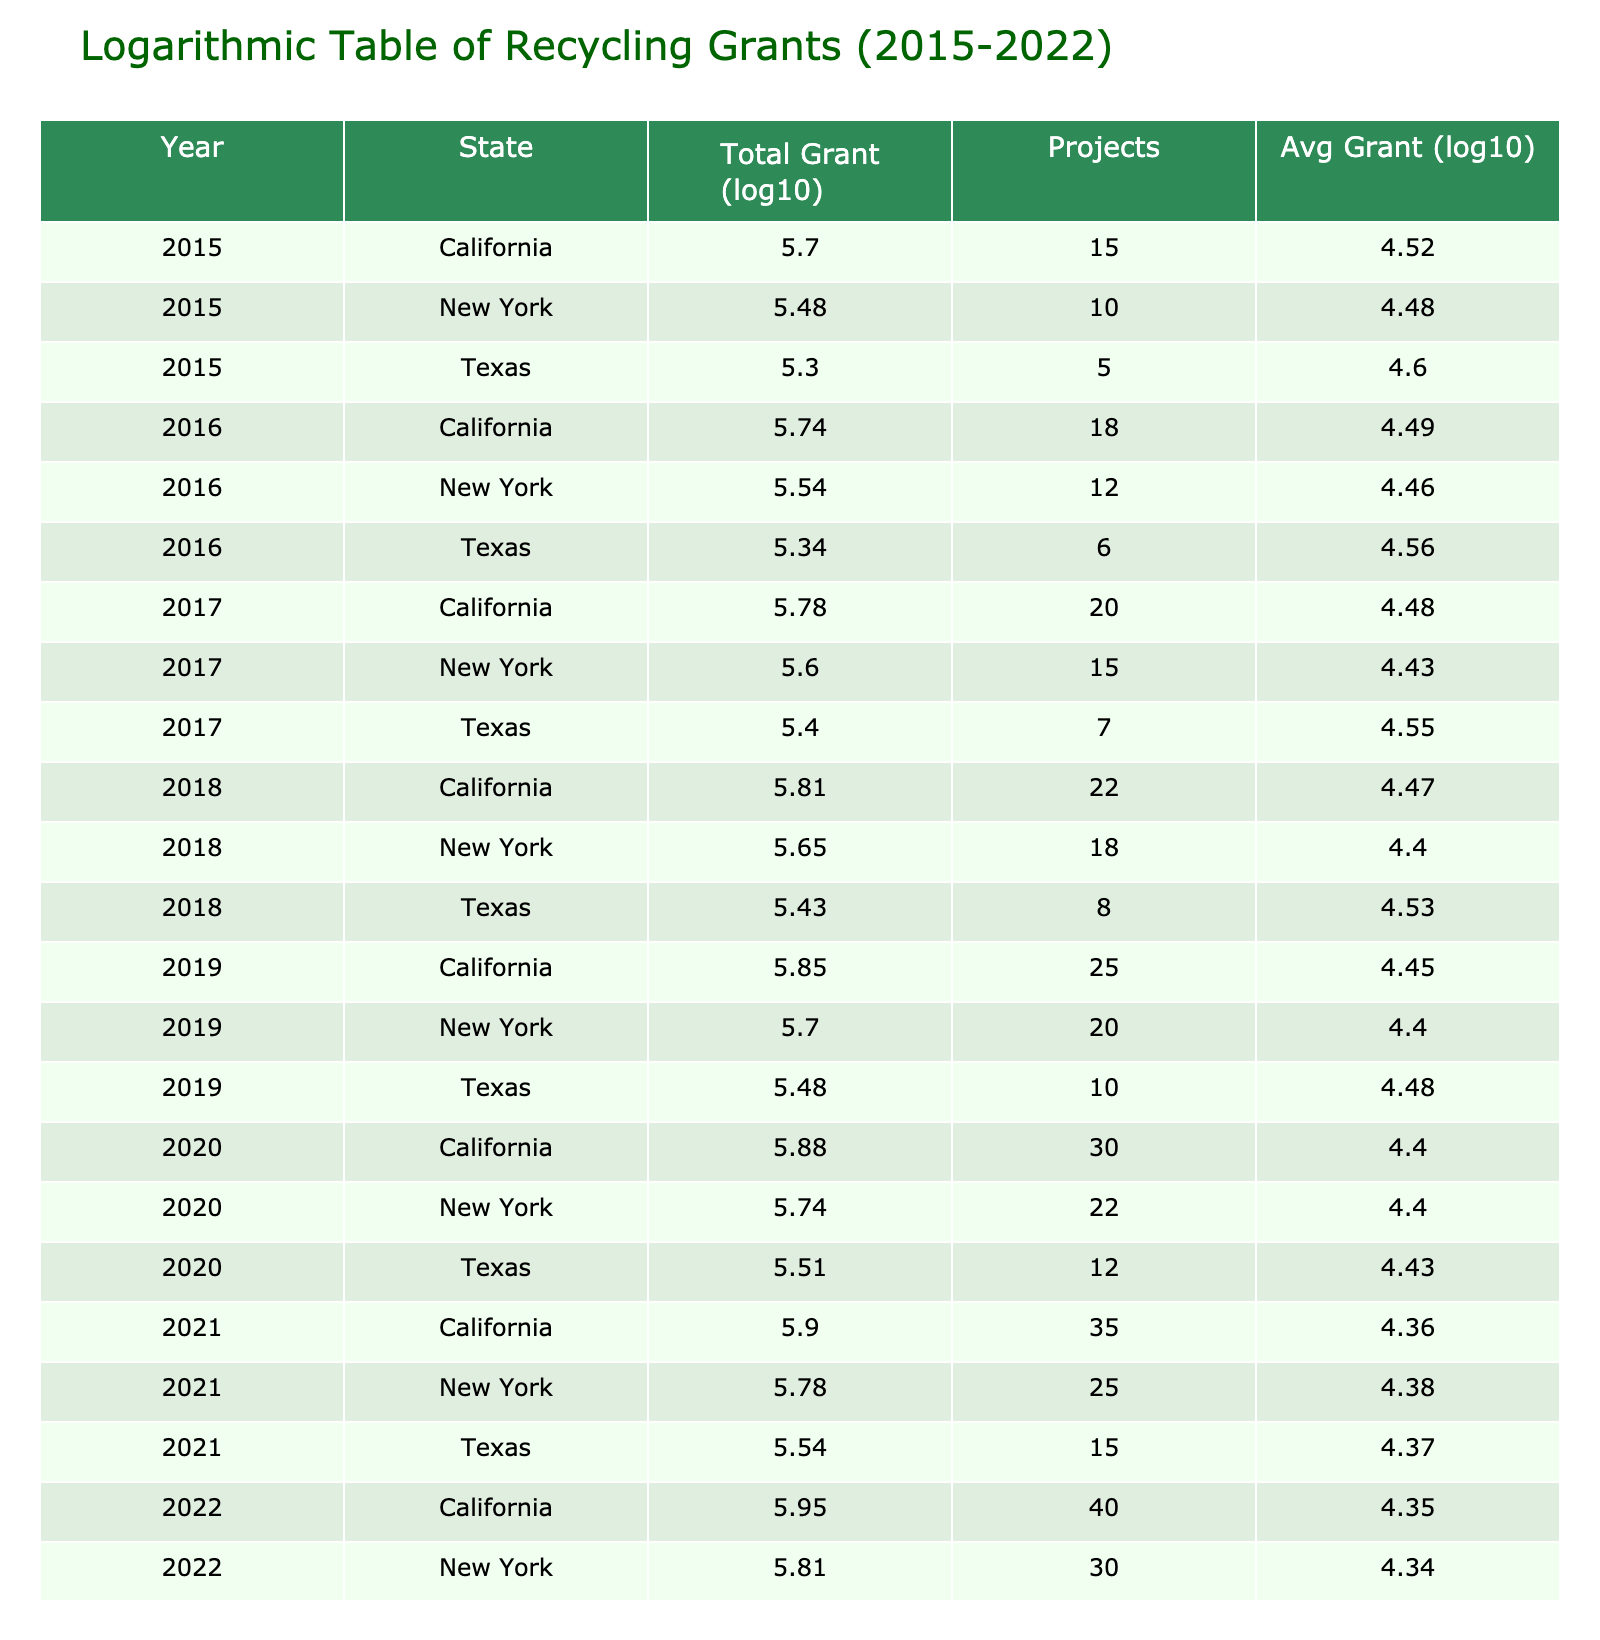What was the total grant amount for Texas in 2016? In the row for Texas in 2016, the Total Grant Amount USD is listed as 220000.
Answer: 220000 Which year had the highest average grant amount per project in California? By looking at the Average Grant Amount Per Project USD for California over the years, we find that in 2015 it was 33333.33, in 2016 it was 30555.56, in 2017 it was 30000.00, in 2018 it was 29545.45, in 2019 it was 28000.00, in 2020 it was 25000.00, in 2021 it was 22857.14, and in 2022 it was 22500.00. The highest average occurred in 2015.
Answer: 2015 Is the total grant amount for New York higher in 2022 than in 2021? The total grant amount for New York in 2022 is 650000, while in 2021 it is 600000. Since 650000 is greater than 600000, the answer is yes.
Answer: Yes What is the total number of projects funded in Texas from 2015 to 2022? By summing the Number of Projects column for Texas across the years: 5 (2015) + 6 (2016) + 7 (2017) + 8 (2018) + 10 (2019) + 12 (2020) + 15 (2021) + 20 (2022) = 73 projects in total.
Answer: 73 In which year and state was the average grant amount per project the lowest? Analyzing the Average Grant Amount Per Project USD across all years and states, we find that Texas in 2022 has the lowest value of 20000.00. It's the only instance of average grant amount being below the others.
Answer: Texas, 2022 